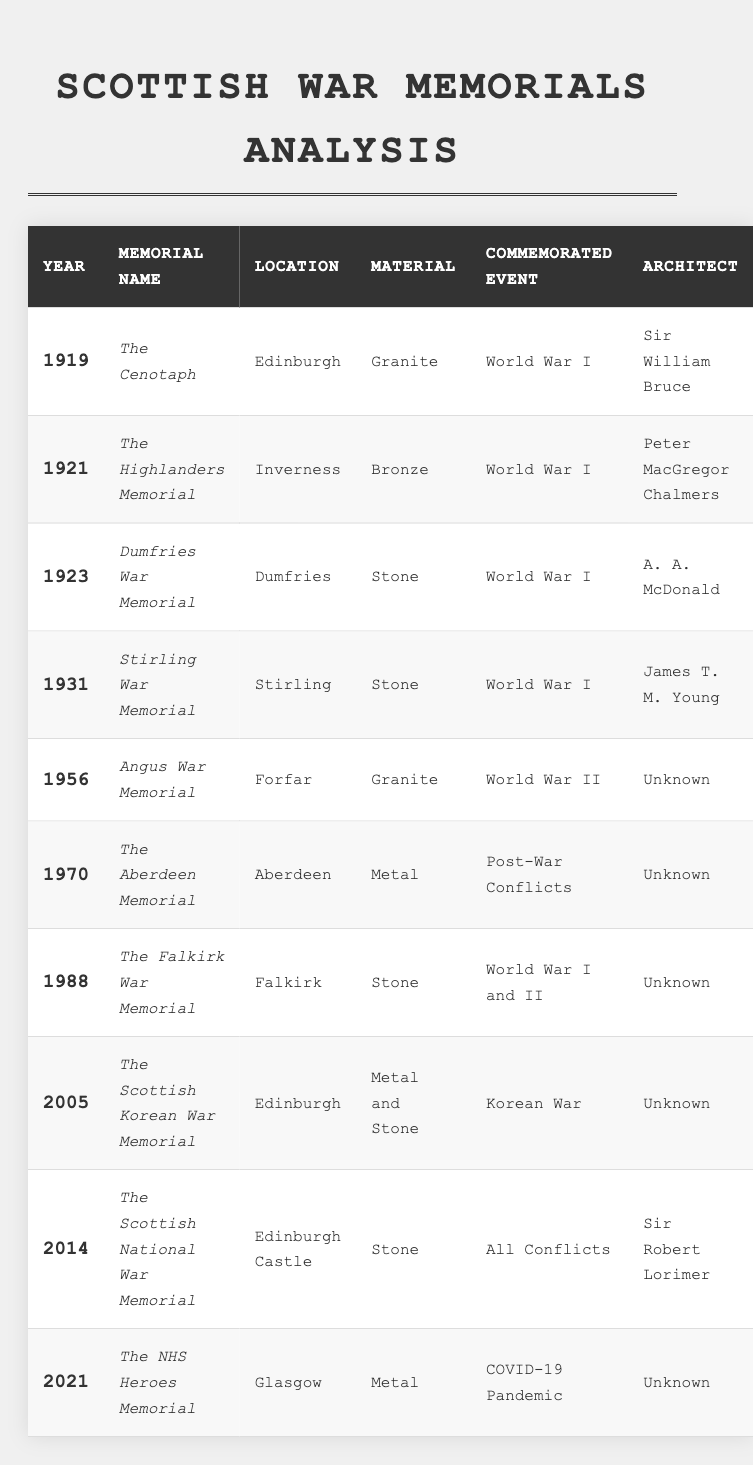What year was The Cenotaph installed? The table shows that The Cenotaph was installed in 1919.
Answer: 1919 Which war memorial was located in Inverness? According to the table, The Highlanders Memorial is located in Inverness.
Answer: The Highlanders Memorial How many war memorials were dedicated to World War I? From the table, we find that there are 5 memorials dedicated to World War I: The Cenotaph, The Highlanders Memorial, Dumfries War Memorial, Stirling War Memorial, and The Falkirk War Memorial.
Answer: 5 What material was used for The Scottish National War Memorial? The table indicates that The Scottish National War Memorial is made of stone.
Answer: Stone Which memorial was added most recently? The latest entry in the table is The NHS Heroes Memorial, installed in 2021, making it the most recent addition.
Answer: The NHS Heroes Memorial How many memorials were built after World War II? Looking at the table, there are 4 memorials installed after World War II: The Aberdeen Memorial (1970), The Falkirk War Memorial (1988), The Scottish Korean War Memorial (2005), and The NHS Heroes Memorial (2021).
Answer: 4 What is the total number of memorials listed in the table? By counting the entries in the table, there are 10 memorials mentioned.
Answer: 10 Is there any memorial that commemorates the COVID-19 Pandemic? Yes, The NHS Heroes Memorial specifically commemorates the COVID-19 Pandemic, as indicated in the table.
Answer: Yes Which architect designed the Stirling War Memorial? The table states that the architect for Stirling War Memorial is James T. M. Young.
Answer: James T. M. Young Which material was most commonly used for memorials before 1950? Reviewing the table, stone appears most frequently before 1950, being used for Dumfries War Memorial (1923) and Stirling War Memorial (1931), while granite was used for The Cenotaph (1919) and Angus War Memorial (1956). Thus, stone is used for 2 memorials before 1950.
Answer: Stone What percentage of memorials commemorate World War I? There are 5 World War I memorials out of a total of 10 memorials, which gives a percentage of (5/10)*100 = 50%.
Answer: 50% 